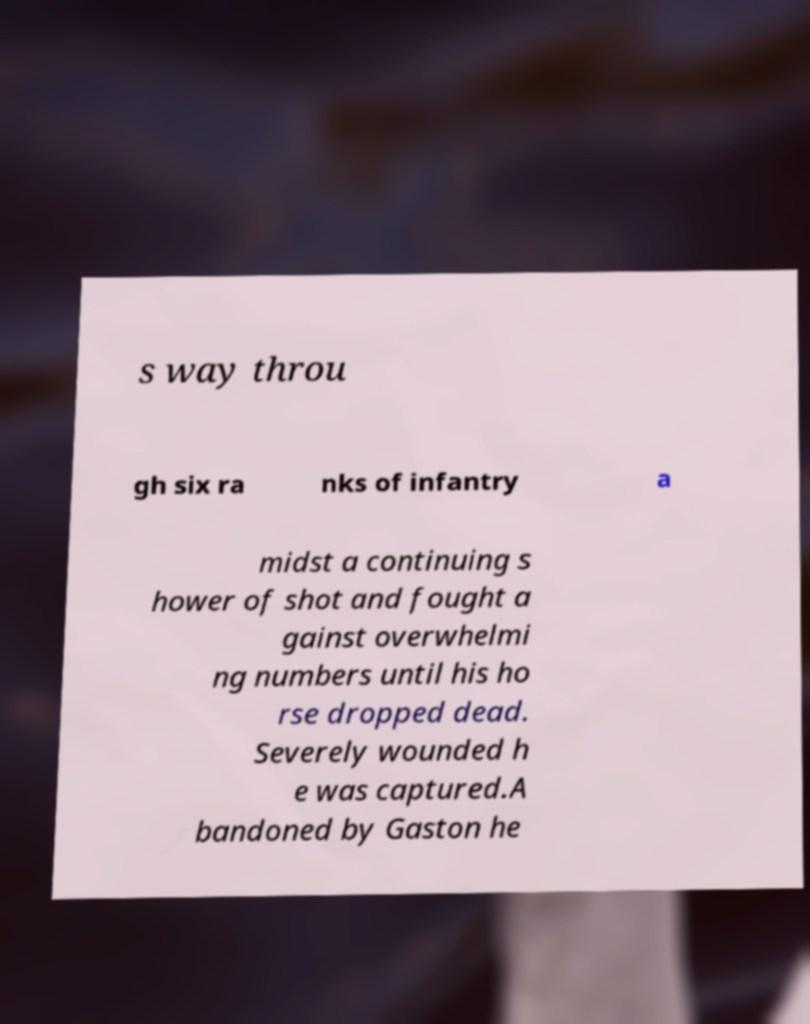Could you extract and type out the text from this image? s way throu gh six ra nks of infantry a midst a continuing s hower of shot and fought a gainst overwhelmi ng numbers until his ho rse dropped dead. Severely wounded h e was captured.A bandoned by Gaston he 